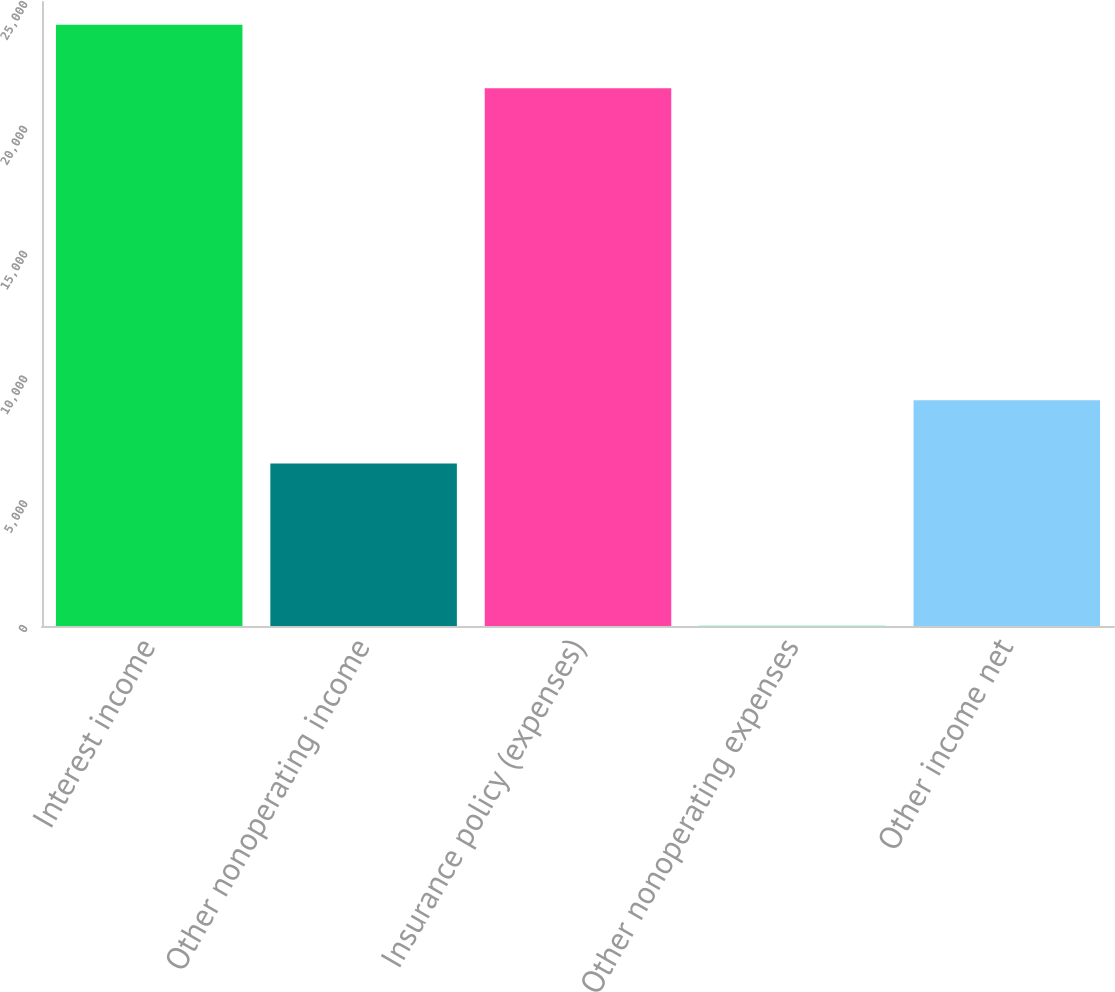Convert chart. <chart><loc_0><loc_0><loc_500><loc_500><bar_chart><fcel>Interest income<fcel>Other nonoperating income<fcel>Insurance policy (expenses)<fcel>Other nonoperating expenses<fcel>Other income net<nl><fcel>24093<fcel>6510<fcel>21548<fcel>7<fcel>9048<nl></chart> 